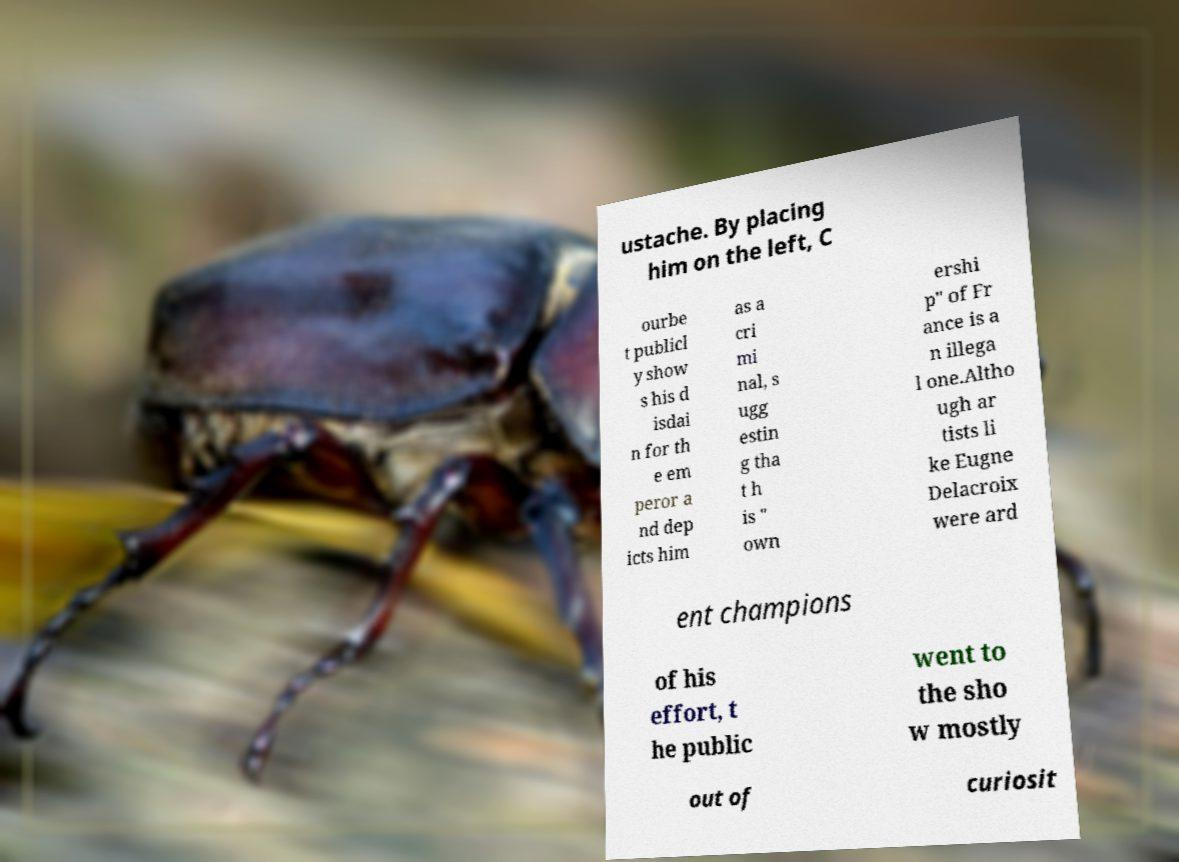Please read and relay the text visible in this image. What does it say? ustache. By placing him on the left, C ourbe t publicl y show s his d isdai n for th e em peror a nd dep icts him as a cri mi nal, s ugg estin g tha t h is " own ershi p" of Fr ance is a n illega l one.Altho ugh ar tists li ke Eugne Delacroix were ard ent champions of his effort, t he public went to the sho w mostly out of curiosit 